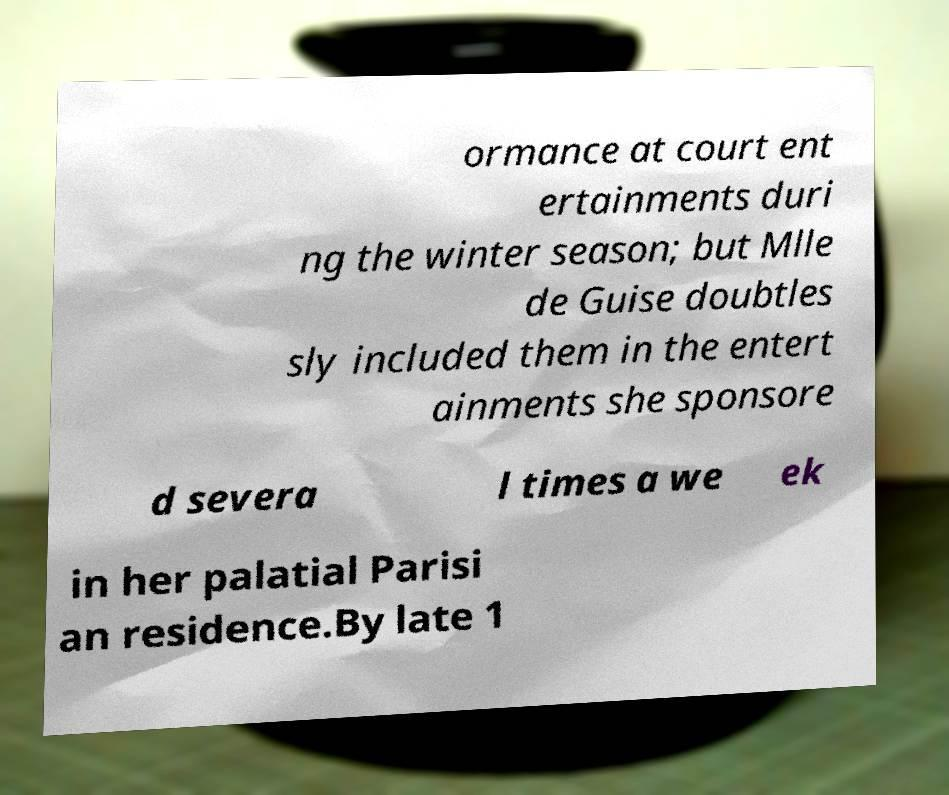For documentation purposes, I need the text within this image transcribed. Could you provide that? ormance at court ent ertainments duri ng the winter season; but Mlle de Guise doubtles sly included them in the entert ainments she sponsore d severa l times a we ek in her palatial Parisi an residence.By late 1 